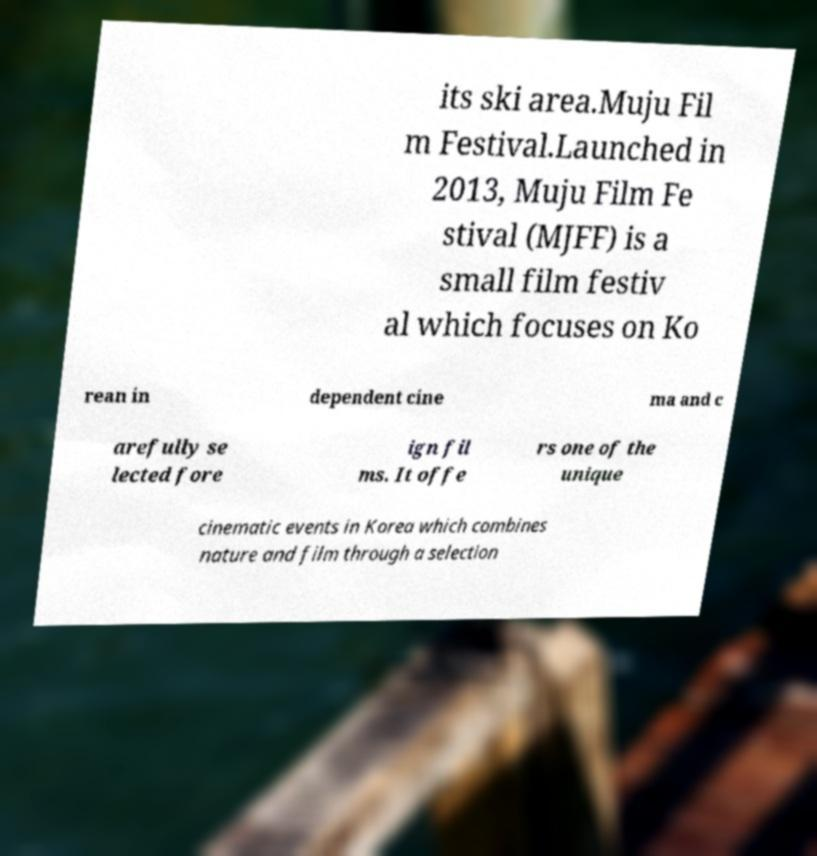Can you accurately transcribe the text from the provided image for me? its ski area.Muju Fil m Festival.Launched in 2013, Muju Film Fe stival (MJFF) is a small film festiv al which focuses on Ko rean in dependent cine ma and c arefully se lected fore ign fil ms. It offe rs one of the unique cinematic events in Korea which combines nature and film through a selection 